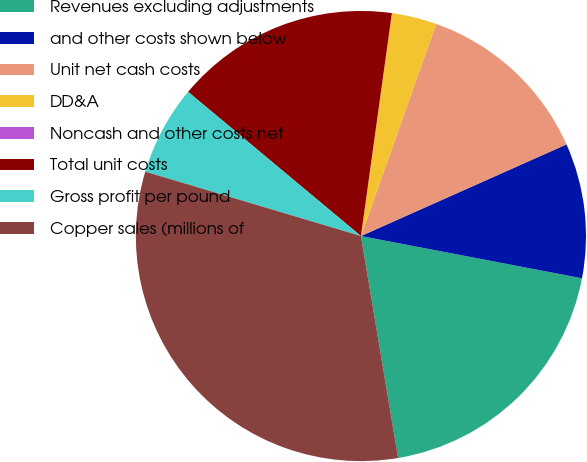Convert chart. <chart><loc_0><loc_0><loc_500><loc_500><pie_chart><fcel>Revenues excluding adjustments<fcel>and other costs shown below<fcel>Unit net cash costs<fcel>DD&A<fcel>Noncash and other costs net<fcel>Total unit costs<fcel>Gross profit per pound<fcel>Copper sales (millions of<nl><fcel>19.35%<fcel>9.68%<fcel>12.9%<fcel>3.23%<fcel>0.0%<fcel>16.13%<fcel>6.45%<fcel>32.26%<nl></chart> 